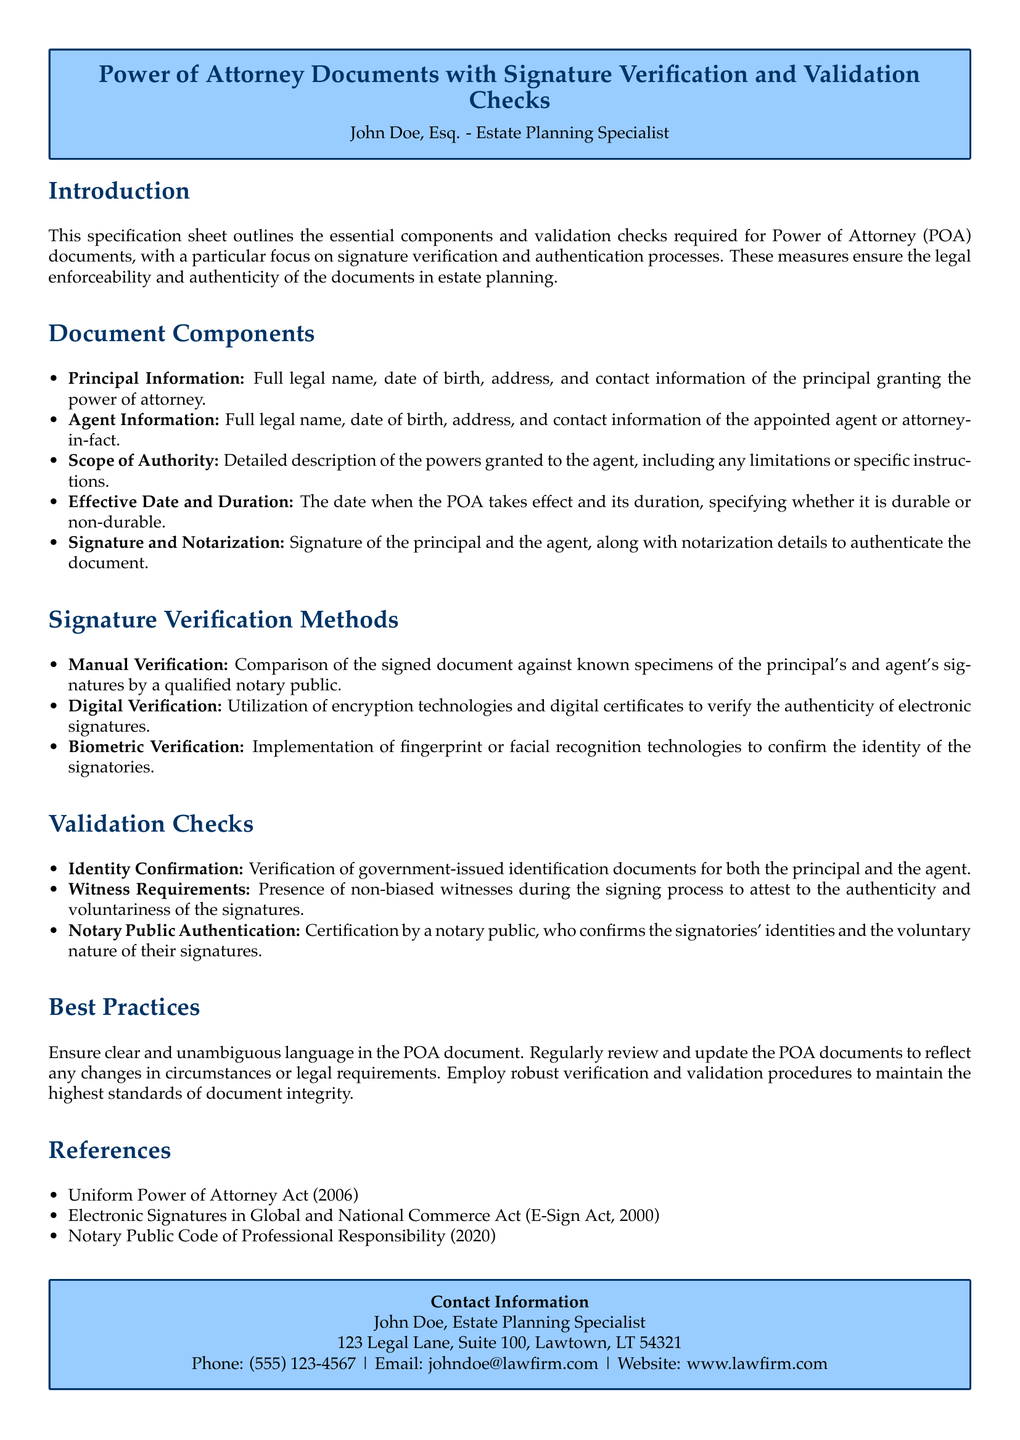What is the title of the document? The title reflects the main subject of the document, which is to outline the components and verification processes for Power of Attorney documents.
Answer: Power of Attorney Documents with Signature Verification and Validation Checks Who is the author of the document? The document lists the author at the top, indicating their profession and area of specialization.
Answer: John Doe, Esq What is the effective date and duration of the Power of Attorney referred to in the document? The document states the need for detailing the effective date and duration within the scope of authority section.
Answer: Not specified What verification method involves utilizing encryption technologies? The specific verification method mentioned in the document that employs technology for signature verification.
Answer: Digital Verification What is required to ensure the authenticity of signatures during the signing process? The document emphasizes the presence of unbiased observers to validate the signing process.
Answer: Witness Requirements Which act relates to electronic signatures mentioned in the document? This act governs the usage of electronic signatures, noted in the references section of the document.
Answer: Electronic Signatures in Global and National Commerce Act (E-Sign Act, 2000) What must the notary public certify? The notary public’s role includes confirming identities and the voluntary nature of signatures, as outlined under validation checks.
Answer: Identity and voluntary nature of signatures What is mentioned as a best practice in the document? The best practice section outlines recommendations for maintaining the integrity and clarity of Power of Attorney documents.
Answer: Review and update documents regularly What type of checks are emphasized for ensuring document integrity? The document outlines the necessity of verification and validation checks to uphold the trustworthiness of the Power of Attorney.
Answer: Verification and validation checks 